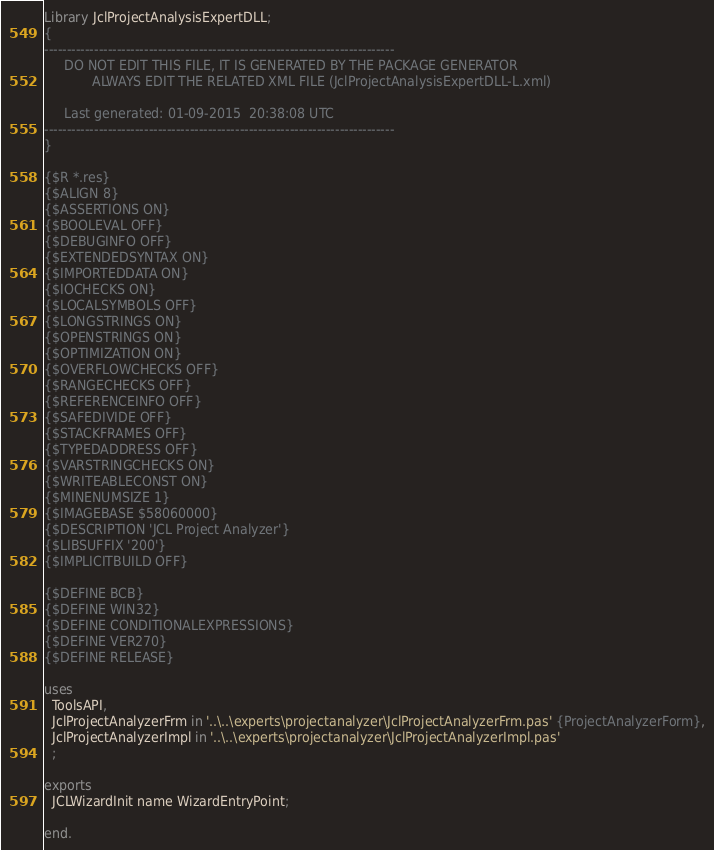<code> <loc_0><loc_0><loc_500><loc_500><_Pascal_>Library JclProjectAnalysisExpertDLL;
{
-----------------------------------------------------------------------------
     DO NOT EDIT THIS FILE, IT IS GENERATED BY THE PACKAGE GENERATOR
            ALWAYS EDIT THE RELATED XML FILE (JclProjectAnalysisExpertDLL-L.xml)

     Last generated: 01-09-2015  20:38:08 UTC
-----------------------------------------------------------------------------
}

{$R *.res}
{$ALIGN 8}
{$ASSERTIONS ON}
{$BOOLEVAL OFF}
{$DEBUGINFO OFF}
{$EXTENDEDSYNTAX ON}
{$IMPORTEDDATA ON}
{$IOCHECKS ON}
{$LOCALSYMBOLS OFF}
{$LONGSTRINGS ON}
{$OPENSTRINGS ON}
{$OPTIMIZATION ON}
{$OVERFLOWCHECKS OFF}
{$RANGECHECKS OFF}
{$REFERENCEINFO OFF}
{$SAFEDIVIDE OFF}
{$STACKFRAMES OFF}
{$TYPEDADDRESS OFF}
{$VARSTRINGCHECKS ON}
{$WRITEABLECONST ON}
{$MINENUMSIZE 1}
{$IMAGEBASE $58060000}
{$DESCRIPTION 'JCL Project Analyzer'}
{$LIBSUFFIX '200'}
{$IMPLICITBUILD OFF}

{$DEFINE BCB}
{$DEFINE WIN32}
{$DEFINE CONDITIONALEXPRESSIONS}
{$DEFINE VER270}
{$DEFINE RELEASE}

uses
  ToolsAPI,
  JclProjectAnalyzerFrm in '..\..\experts\projectanalyzer\JclProjectAnalyzerFrm.pas' {ProjectAnalyzerForm},
  JclProjectAnalyzerImpl in '..\..\experts\projectanalyzer\JclProjectAnalyzerImpl.pas' 
  ;

exports
  JCLWizardInit name WizardEntryPoint;

end.
</code> 